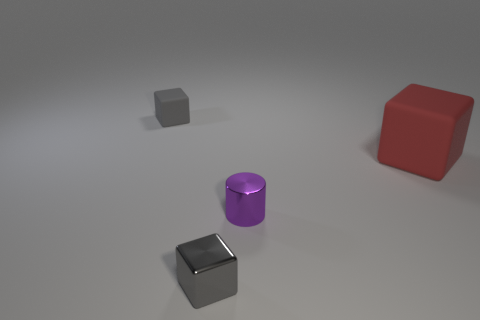Are the tiny purple thing and the small cube behind the small gray metal cube made of the same material?
Your answer should be compact. No. The object that is both behind the tiny cylinder and left of the large rubber block is what color?
Offer a terse response. Gray. What number of cylinders are either red objects or gray metal things?
Provide a short and direct response. 0. Do the purple metal object and the thing that is left of the metal block have the same shape?
Your answer should be compact. No. There is a thing that is on the left side of the small purple metal object and in front of the large rubber block; how big is it?
Ensure brevity in your answer.  Small. What is the shape of the tiny purple thing?
Keep it short and to the point. Cylinder. There is a small gray block in front of the small purple thing; is there a small purple cylinder that is in front of it?
Keep it short and to the point. No. There is a small thing in front of the tiny purple shiny cylinder; what number of gray cubes are on the left side of it?
Make the answer very short. 1. What material is the other gray block that is the same size as the shiny cube?
Give a very brief answer. Rubber. Does the rubber thing to the right of the small purple cylinder have the same shape as the purple metal thing?
Ensure brevity in your answer.  No. 